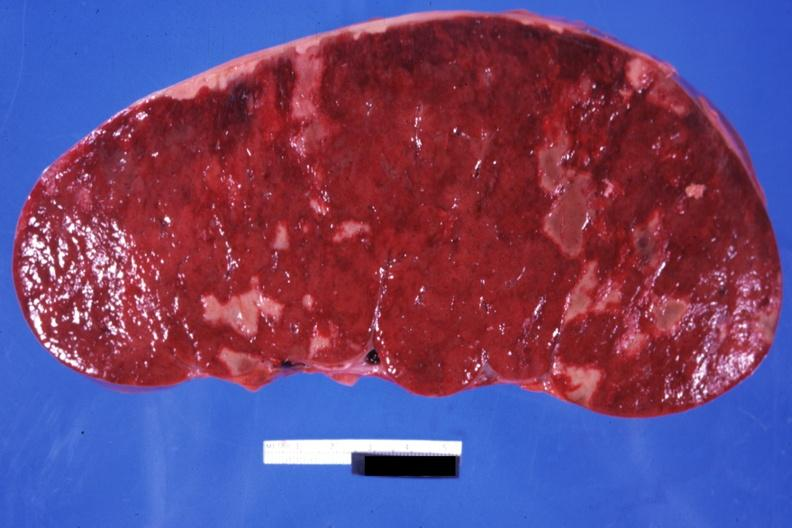what is present?
Answer the question using a single word or phrase. Chronic myelogenous leukemia in blast crisis 